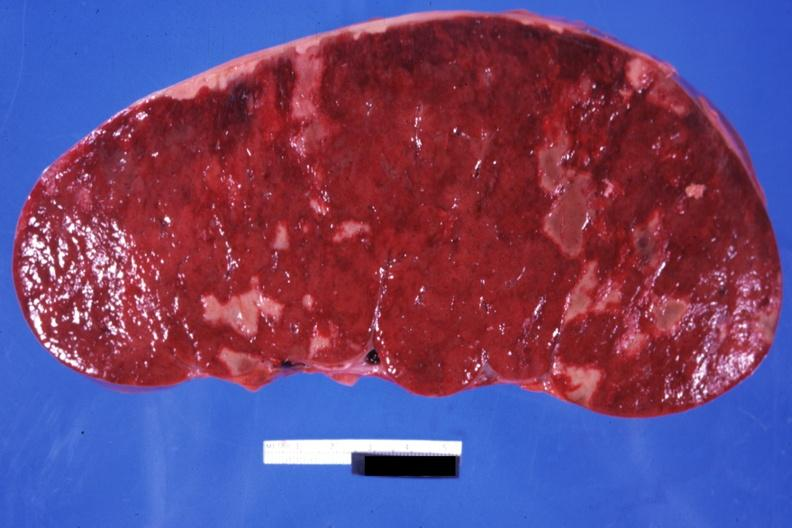what is present?
Answer the question using a single word or phrase. Chronic myelogenous leukemia in blast crisis 